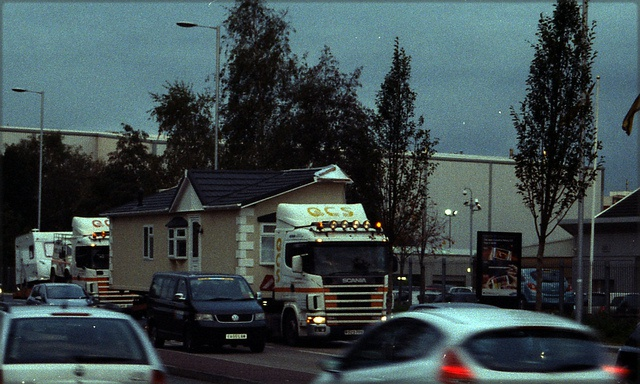Describe the objects in this image and their specific colors. I can see car in teal, black, lightblue, and gray tones, truck in teal, black, gray, darkgray, and lightgreen tones, car in teal, black, navy, gray, and darkgray tones, car in teal, black, navy, blue, and gray tones, and truck in teal, black, gray, darkgray, and maroon tones in this image. 